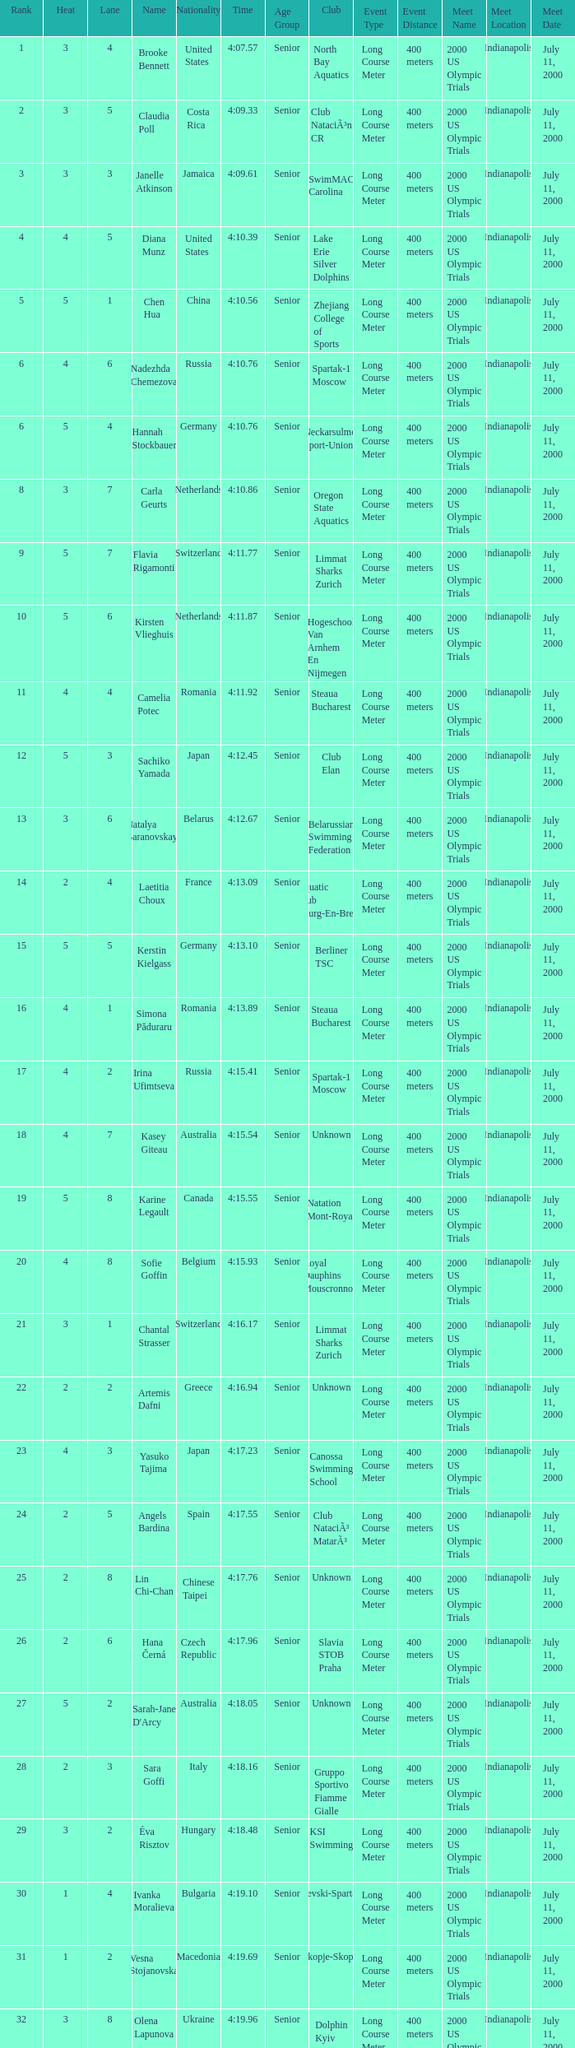Name the average rank with larger than 3 and heat more than 5 None. 